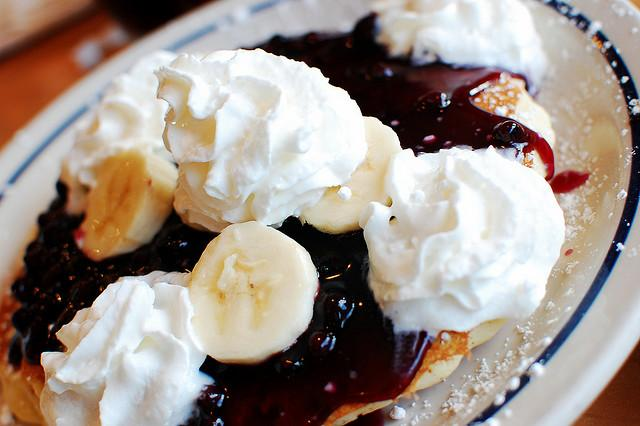What type of breakfast food is this on the plate?

Choices:
A) waffle
B) egg
C) pancake
D) biscuit pancake 